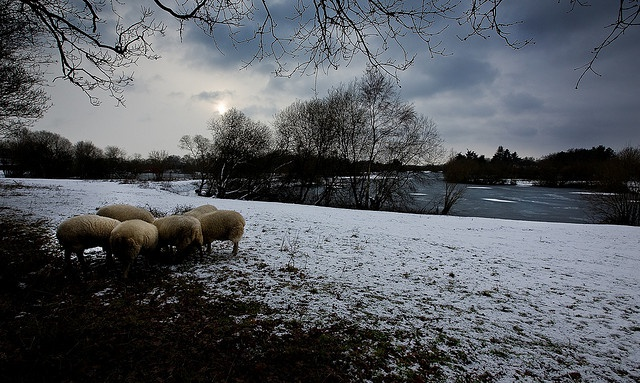Describe the objects in this image and their specific colors. I can see sheep in black and gray tones, sheep in black and gray tones, sheep in black and gray tones, sheep in black and gray tones, and sheep in black and gray tones in this image. 